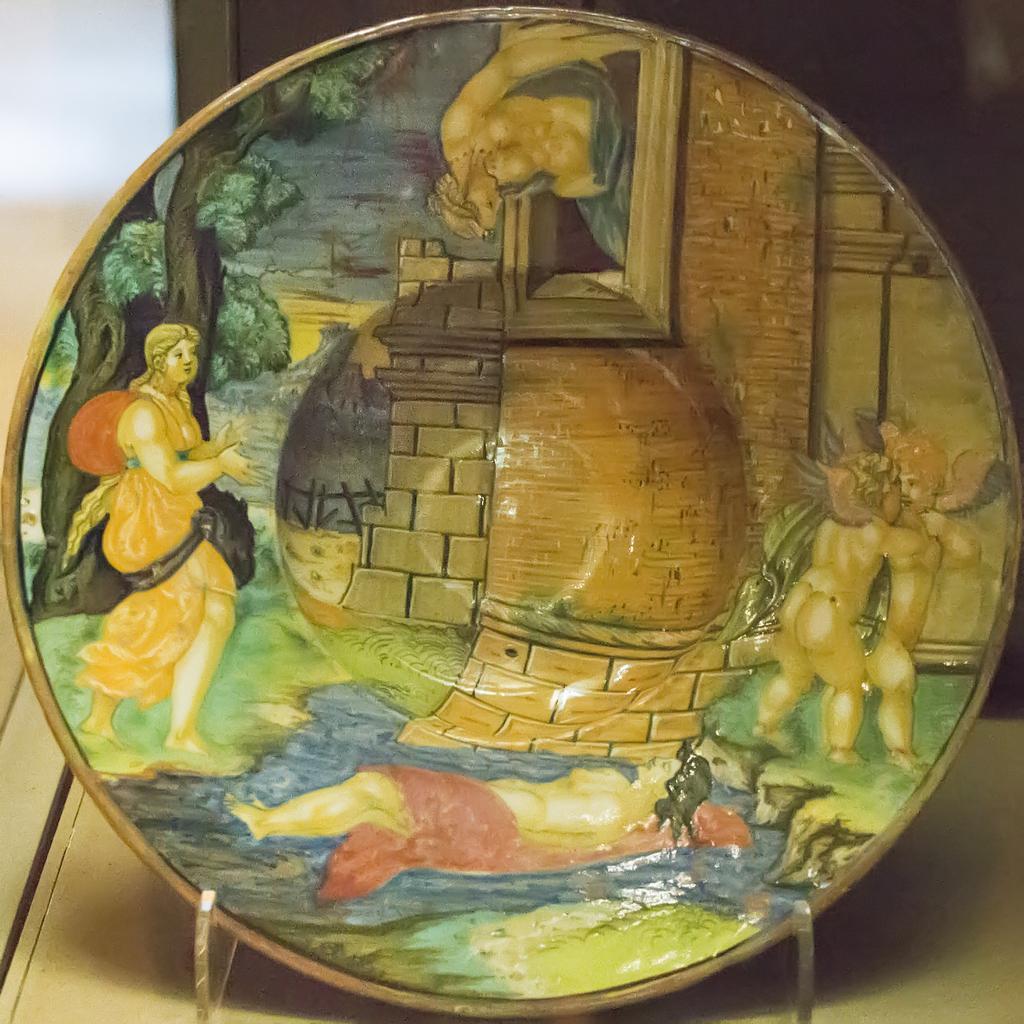Can you describe this image briefly? In this image there is a porcelain in a stand, kept on a table. 